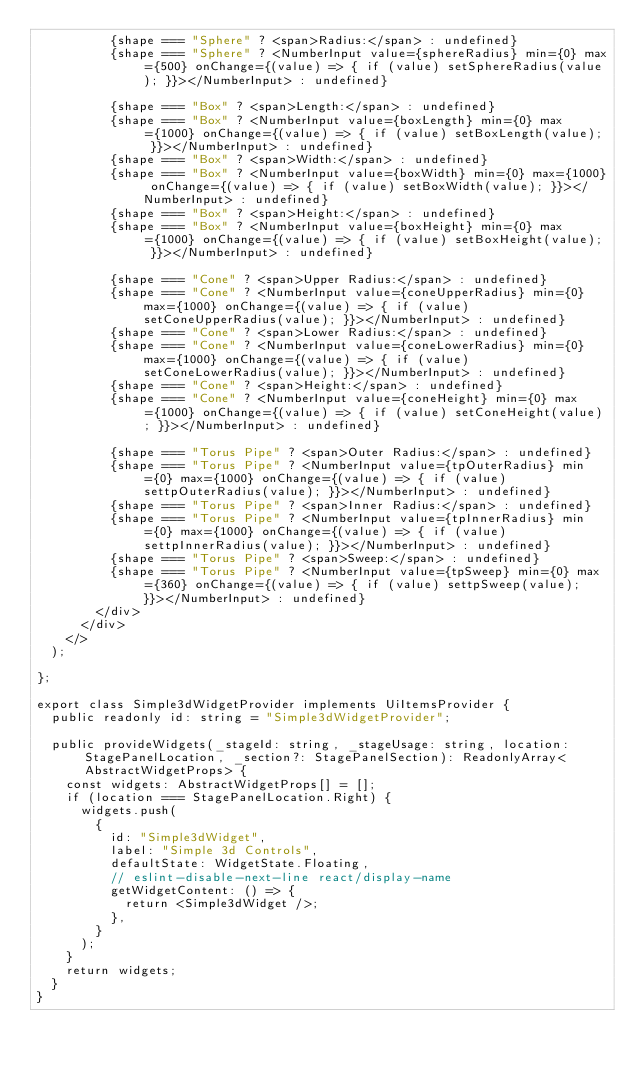Convert code to text. <code><loc_0><loc_0><loc_500><loc_500><_TypeScript_>          {shape === "Sphere" ? <span>Radius:</span> : undefined}
          {shape === "Sphere" ? <NumberInput value={sphereRadius} min={0} max={500} onChange={(value) => { if (value) setSphereRadius(value); }}></NumberInput> : undefined}

          {shape === "Box" ? <span>Length:</span> : undefined}
          {shape === "Box" ? <NumberInput value={boxLength} min={0} max={1000} onChange={(value) => { if (value) setBoxLength(value); }}></NumberInput> : undefined}
          {shape === "Box" ? <span>Width:</span> : undefined}
          {shape === "Box" ? <NumberInput value={boxWidth} min={0} max={1000} onChange={(value) => { if (value) setBoxWidth(value); }}></NumberInput> : undefined}
          {shape === "Box" ? <span>Height:</span> : undefined}
          {shape === "Box" ? <NumberInput value={boxHeight} min={0} max={1000} onChange={(value) => { if (value) setBoxHeight(value); }}></NumberInput> : undefined}

          {shape === "Cone" ? <span>Upper Radius:</span> : undefined}
          {shape === "Cone" ? <NumberInput value={coneUpperRadius} min={0} max={1000} onChange={(value) => { if (value) setConeUpperRadius(value); }}></NumberInput> : undefined}
          {shape === "Cone" ? <span>Lower Radius:</span> : undefined}
          {shape === "Cone" ? <NumberInput value={coneLowerRadius} min={0} max={1000} onChange={(value) => { if (value) setConeLowerRadius(value); }}></NumberInput> : undefined}
          {shape === "Cone" ? <span>Height:</span> : undefined}
          {shape === "Cone" ? <NumberInput value={coneHeight} min={0} max={1000} onChange={(value) => { if (value) setConeHeight(value); }}></NumberInput> : undefined}

          {shape === "Torus Pipe" ? <span>Outer Radius:</span> : undefined}
          {shape === "Torus Pipe" ? <NumberInput value={tpOuterRadius} min={0} max={1000} onChange={(value) => { if (value) settpOuterRadius(value); }}></NumberInput> : undefined}
          {shape === "Torus Pipe" ? <span>Inner Radius:</span> : undefined}
          {shape === "Torus Pipe" ? <NumberInput value={tpInnerRadius} min={0} max={1000} onChange={(value) => { if (value) settpInnerRadius(value); }}></NumberInput> : undefined}
          {shape === "Torus Pipe" ? <span>Sweep:</span> : undefined}
          {shape === "Torus Pipe" ? <NumberInput value={tpSweep} min={0} max={360} onChange={(value) => { if (value) settpSweep(value); }}></NumberInput> : undefined}
        </div>
      </div>
    </>
  );

};

export class Simple3dWidgetProvider implements UiItemsProvider {
  public readonly id: string = "Simple3dWidgetProvider";

  public provideWidgets(_stageId: string, _stageUsage: string, location: StagePanelLocation, _section?: StagePanelSection): ReadonlyArray<AbstractWidgetProps> {
    const widgets: AbstractWidgetProps[] = [];
    if (location === StagePanelLocation.Right) {
      widgets.push(
        {
          id: "Simple3dWidget",
          label: "Simple 3d Controls",
          defaultState: WidgetState.Floating,
          // eslint-disable-next-line react/display-name
          getWidgetContent: () => {
            return <Simple3dWidget />;
          },
        }
      );
    }
    return widgets;
  }
}
</code> 